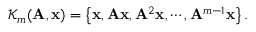<formula> <loc_0><loc_0><loc_500><loc_500>\mathcal { K } _ { m } ( A , x ) = \left \{ x , A x , A ^ { 2 } x , \cdots , A ^ { m - 1 } x \right \} .</formula> 